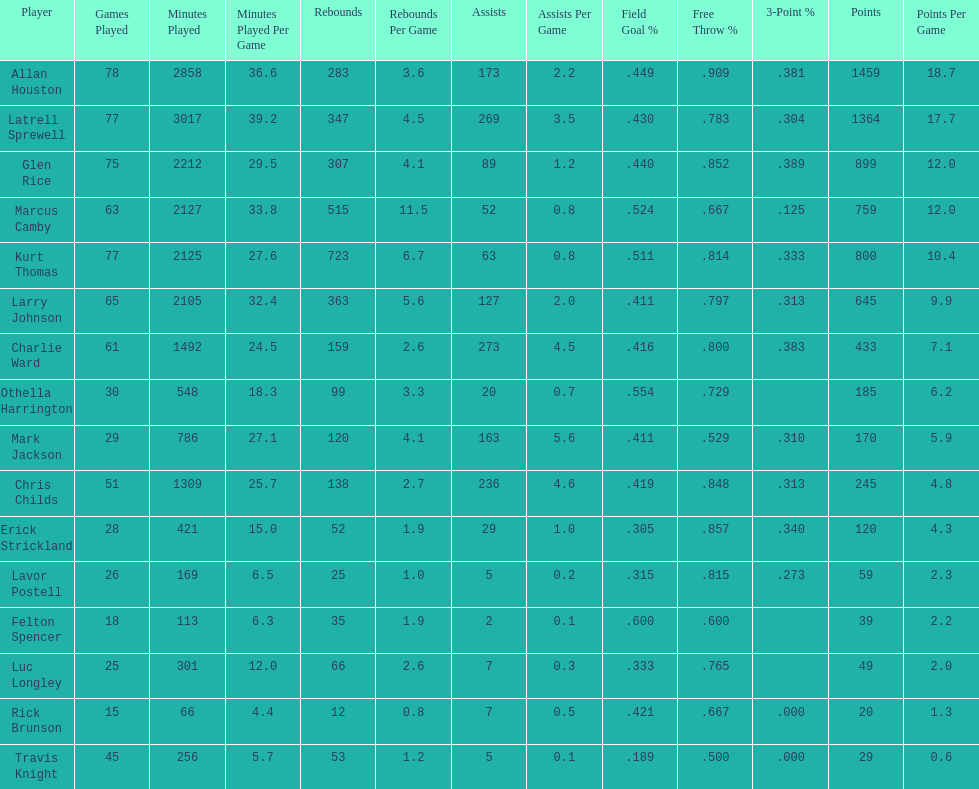How many players had a field goal percentage greater than .500? 4. 